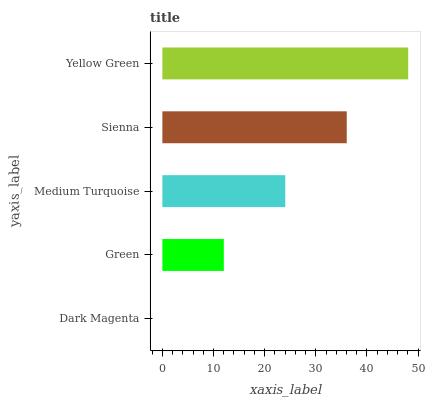Is Dark Magenta the minimum?
Answer yes or no. Yes. Is Yellow Green the maximum?
Answer yes or no. Yes. Is Green the minimum?
Answer yes or no. No. Is Green the maximum?
Answer yes or no. No. Is Green greater than Dark Magenta?
Answer yes or no. Yes. Is Dark Magenta less than Green?
Answer yes or no. Yes. Is Dark Magenta greater than Green?
Answer yes or no. No. Is Green less than Dark Magenta?
Answer yes or no. No. Is Medium Turquoise the high median?
Answer yes or no. Yes. Is Medium Turquoise the low median?
Answer yes or no. Yes. Is Yellow Green the high median?
Answer yes or no. No. Is Dark Magenta the low median?
Answer yes or no. No. 